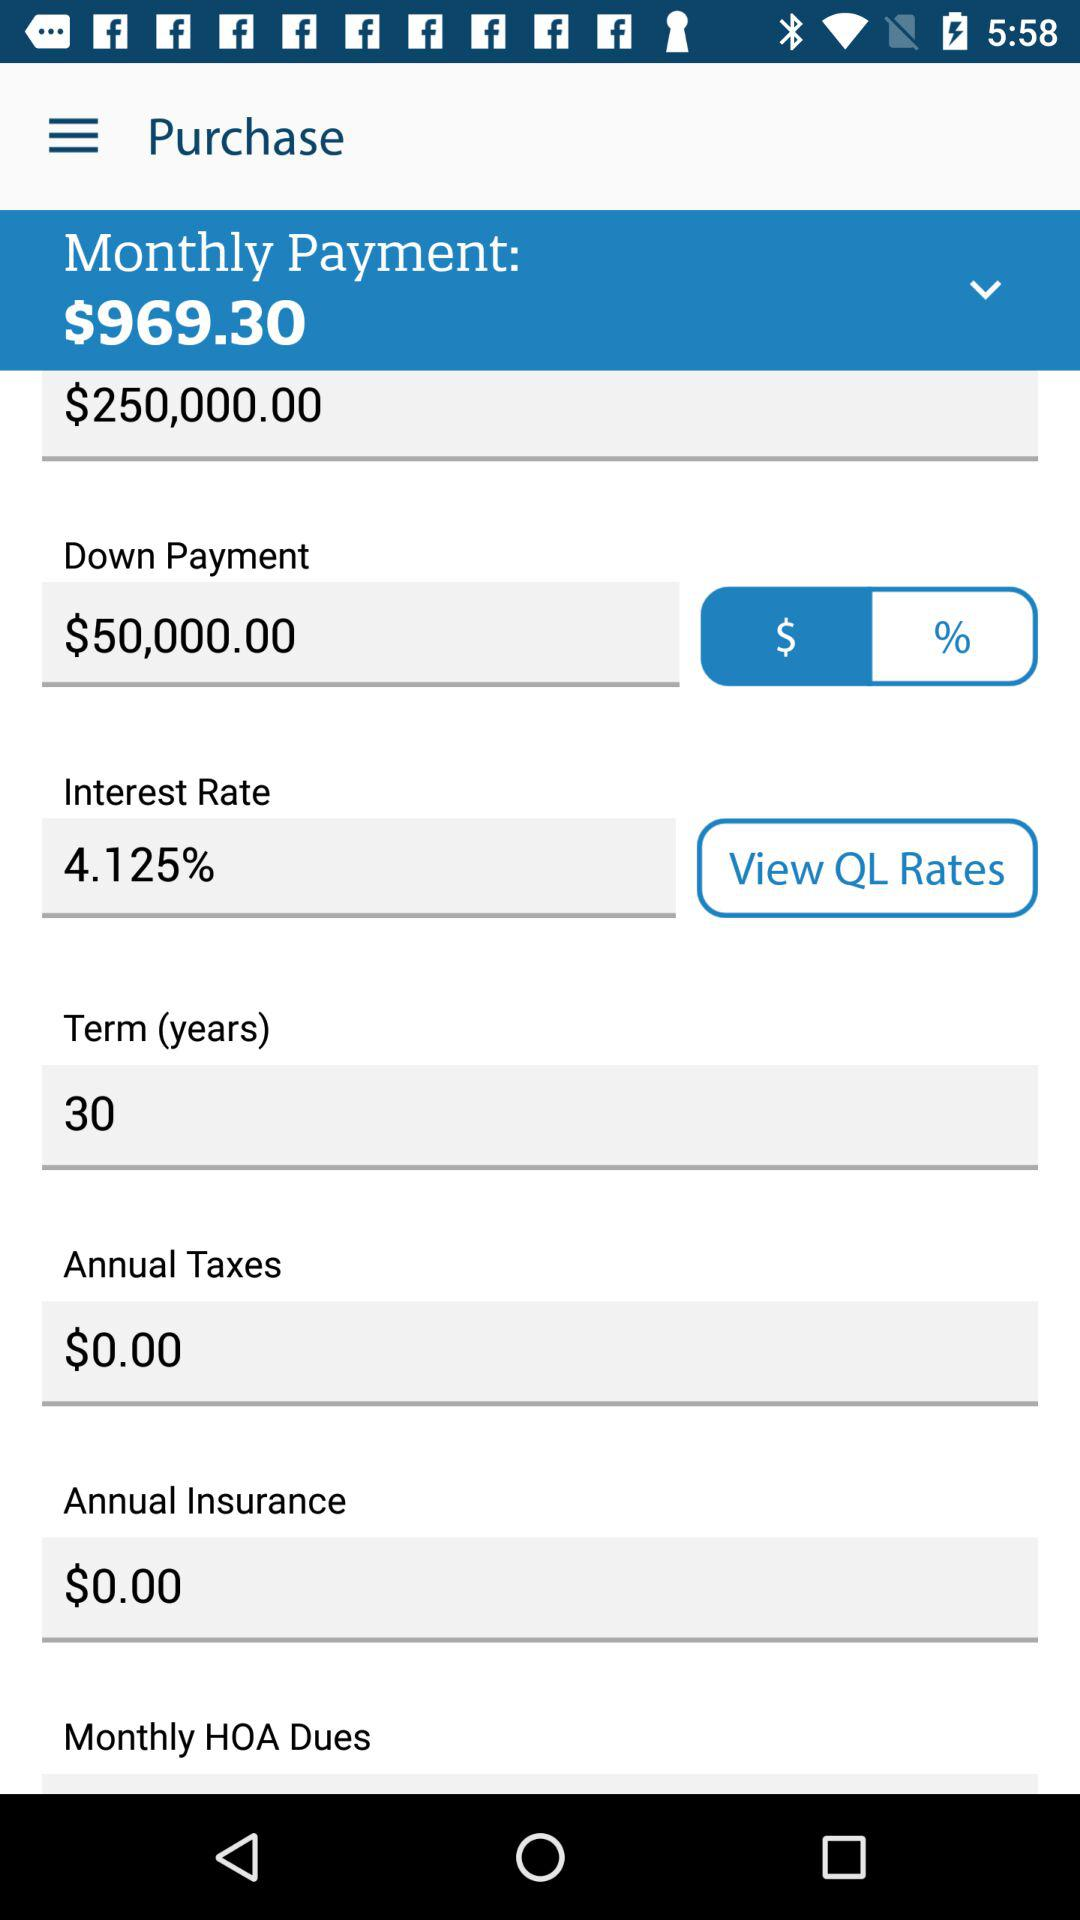What is the amount of the annual tax? The amount of the annual tax is $0. 